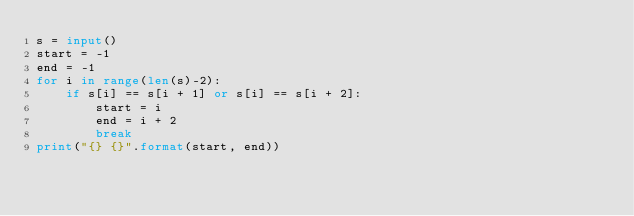<code> <loc_0><loc_0><loc_500><loc_500><_Python_>s = input()
start = -1
end = -1
for i in range(len(s)-2):
    if s[i] == s[i + 1] or s[i] == s[i + 2]:
        start = i
        end = i + 2
        break
print("{} {}".format(start, end))</code> 